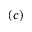Convert formula to latex. <formula><loc_0><loc_0><loc_500><loc_500>( c )</formula> 